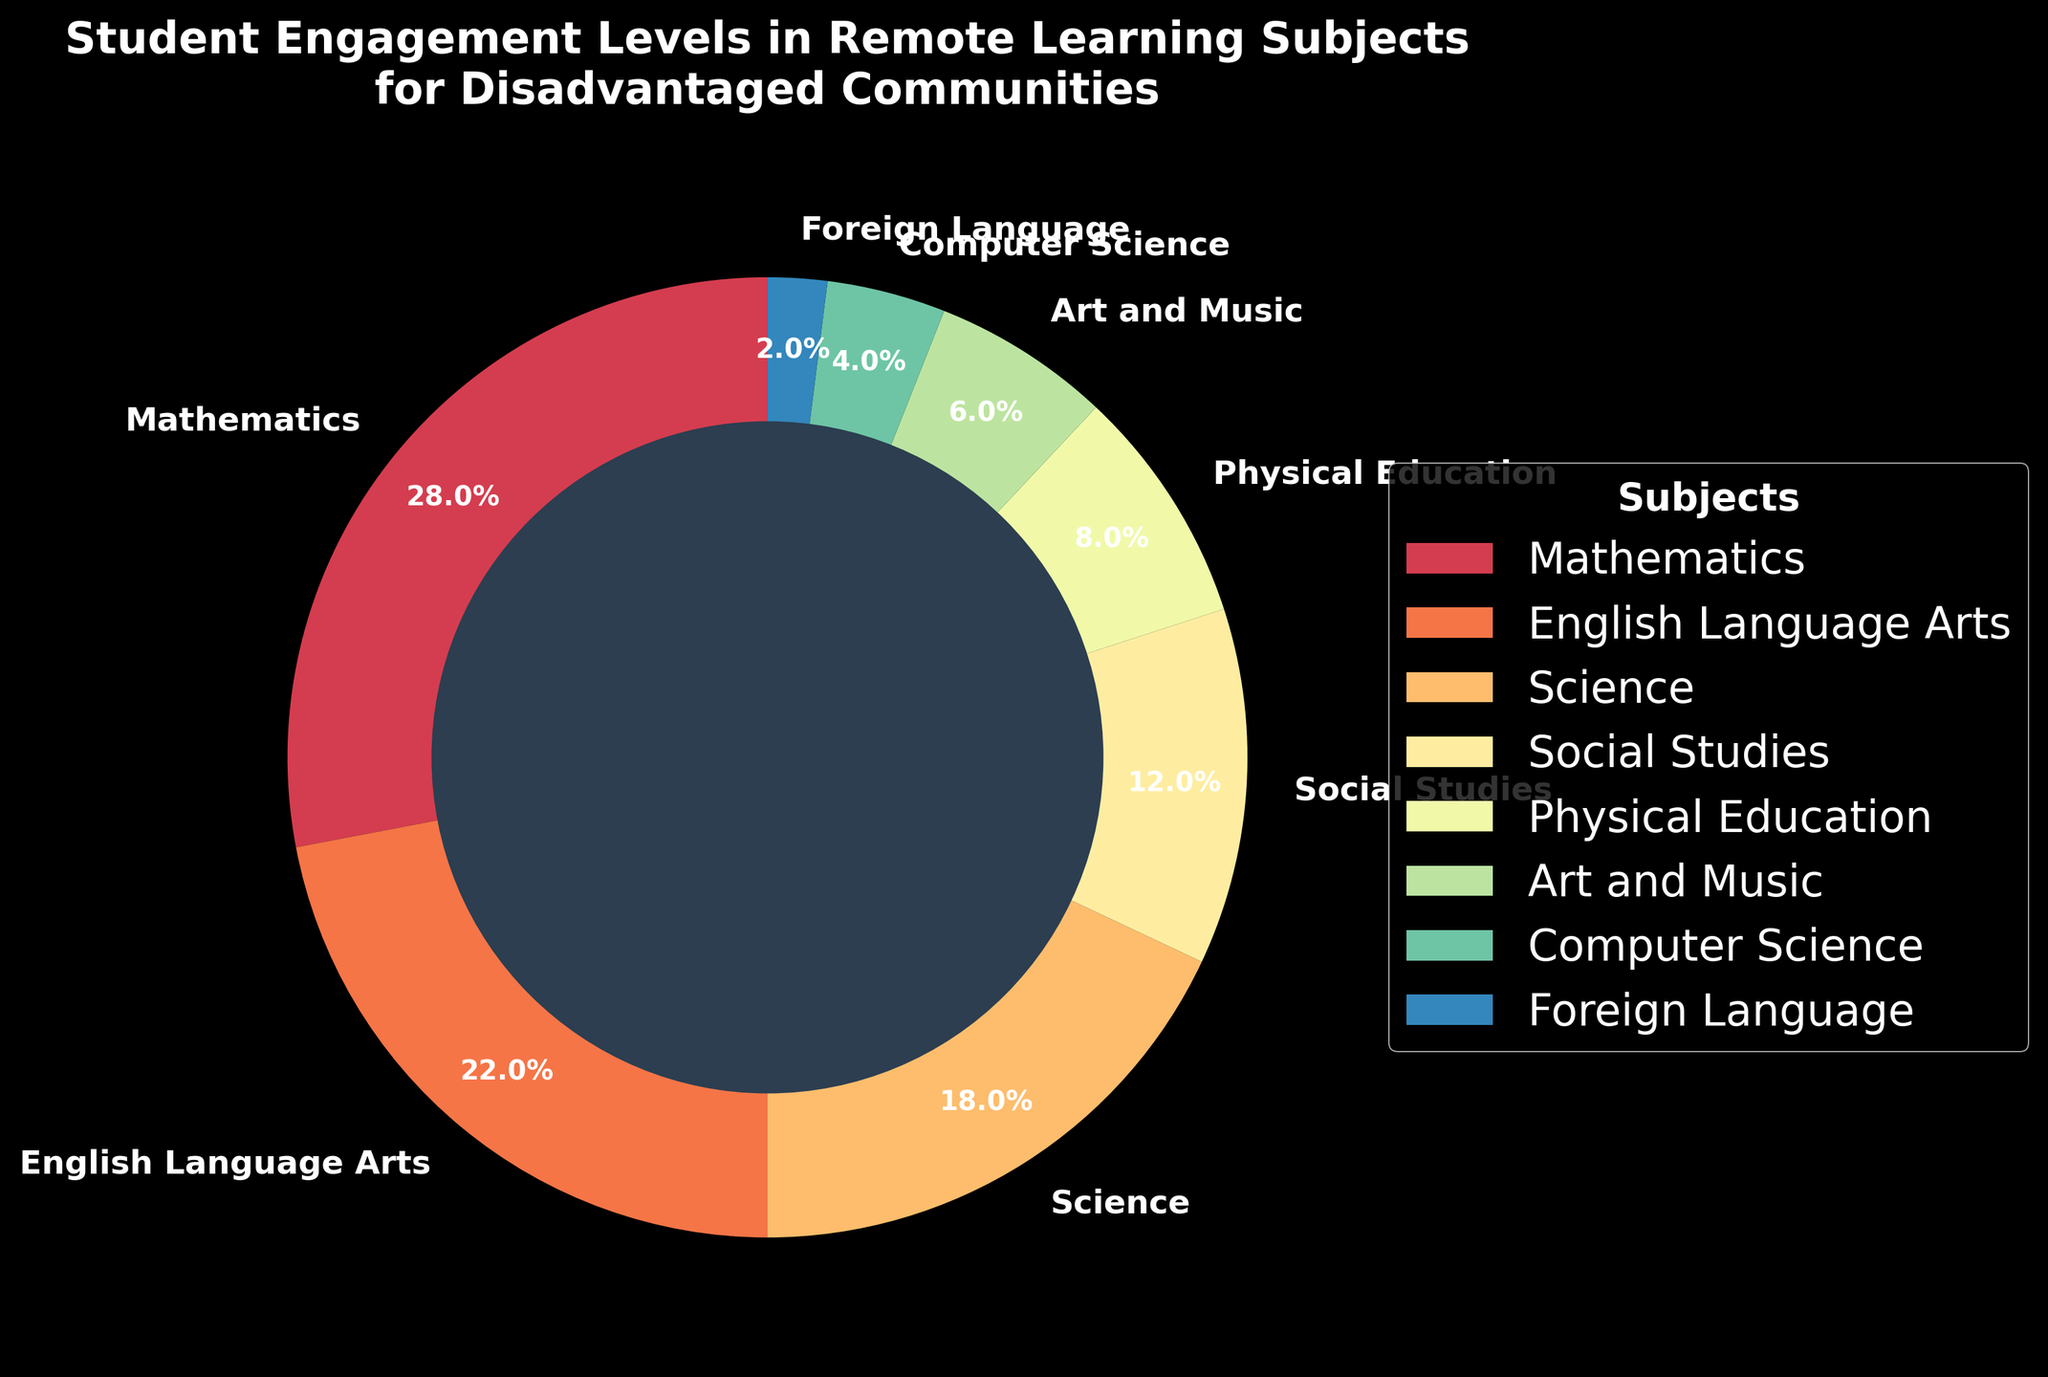What subject has the highest student engagement level in the pie chart? The pie chart shows the relative sizes of engagement levels for different subjects. Mathematics has the largest wedge, indicating the highest engagement percentage.
Answer: Mathematics Which subject has the lowest student engagement level in the pie chart? By observing the sizes of the wedges, Foreign Language has the smallest portion, indicating the lowest engagement percentage.
Answer: Foreign Language How much more engaged are students in Mathematics compared to Physical Education? Mathematics has an engagement percentage of 28% and Physical Education has 8%. The difference is calculated as 28% - 8%.
Answer: 20% What is the total engagement percentage for the core subjects: Mathematics, English Language Arts, Science, and Social Studies? Add the engagement percentages: 28% (Mathematics) + 22% (English Language Arts) + 18% (Science) + 12% (Social Studies).
Answer: 80% Are students more engaged in Art and Music or in Computer Science? By comparing the wedges, Art and Music show 6% engagement while Computer Science shows 4%. Art and Music have a higher engagement percentage.
Answer: Art and Music What is the combined engagement percentage for subjects other than the core subjects? Add the engagement percentages for the non-core subjects: 8% (Physical Education) + 6% (Art and Music) + 4% (Computer Science) + 2% (Foreign Language).
Answer: 20% Which three subjects show the least engagement and what is their combined engagement percentage? The three subjects with the smallest wedges are Foreign Language (2%), Computer Science (4%), and Art and Music (6%). The combined engagement is 2% + 4% + 6%.
Answer: 12% How does the engagement in Science compare to that in English Language Arts? The engagement percentages are 18% for Science and 22% for English Language Arts. English Language Arts has a higher engagement than Science.
Answer: English Language Arts What is the average engagement percentage for Physical Education, Art and Music, and Computer Science? Calculate the average by adding the percentages and dividing by the number of subjects: (8% + 6% + 4%)/3.
Answer: 6% Which subject represented by a darker color has a higher student engagement? The pie chart uses a gradient of colors, with darker colors typically indicating more significant areas. Mathematics with its larger dark wedge signifies a higher engagement.
Answer: Mathematics 